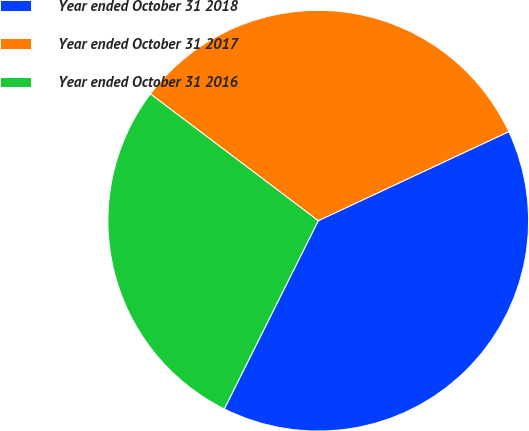Convert chart to OTSL. <chart><loc_0><loc_0><loc_500><loc_500><pie_chart><fcel>Year ended October 31 2018<fcel>Year ended October 31 2017<fcel>Year ended October 31 2016<nl><fcel>39.33%<fcel>32.75%<fcel>27.93%<nl></chart> 